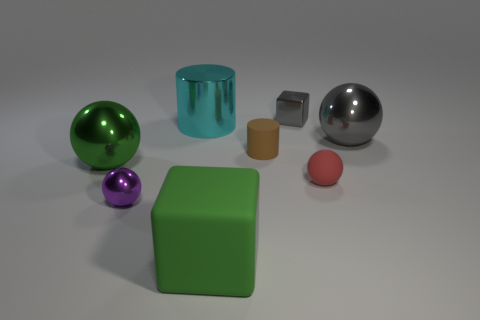Is there a big green metallic sphere?
Offer a very short reply. Yes. What color is the tiny ball left of the small metallic thing behind the large gray sphere?
Make the answer very short. Purple. What material is the small object that is the same shape as the large cyan shiny thing?
Provide a short and direct response. Rubber. What number of gray blocks have the same size as the cyan shiny thing?
Keep it short and to the point. 0. There is a red thing that is the same material as the small brown cylinder; what size is it?
Offer a terse response. Small. What number of big green rubber objects have the same shape as the red object?
Offer a terse response. 0. What number of tiny blue matte things are there?
Offer a terse response. 0. Do the matte object that is to the left of the matte cylinder and the tiny purple thing have the same shape?
Make the answer very short. No. What material is the red sphere that is the same size as the brown thing?
Give a very brief answer. Rubber. Is there a large yellow cylinder made of the same material as the large green block?
Keep it short and to the point. No. 